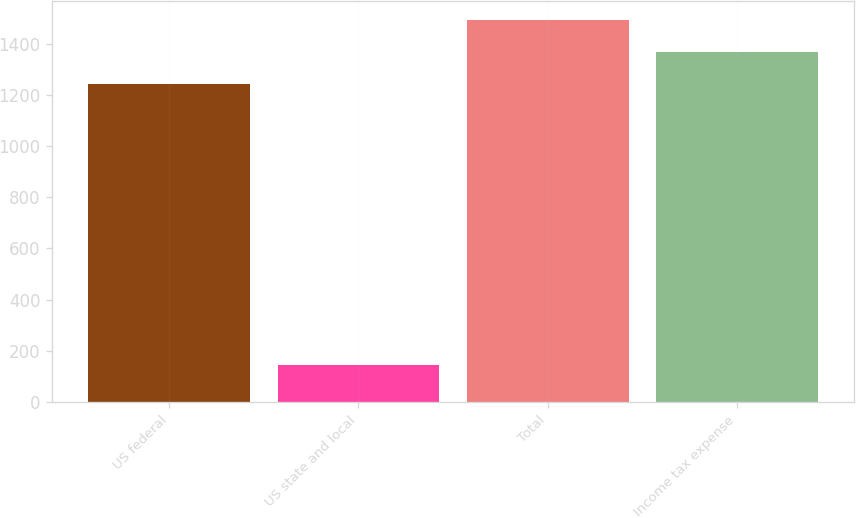Convert chart. <chart><loc_0><loc_0><loc_500><loc_500><bar_chart><fcel>US federal<fcel>US state and local<fcel>Total<fcel>Income tax expense<nl><fcel>1245<fcel>143<fcel>1494<fcel>1369.5<nl></chart> 